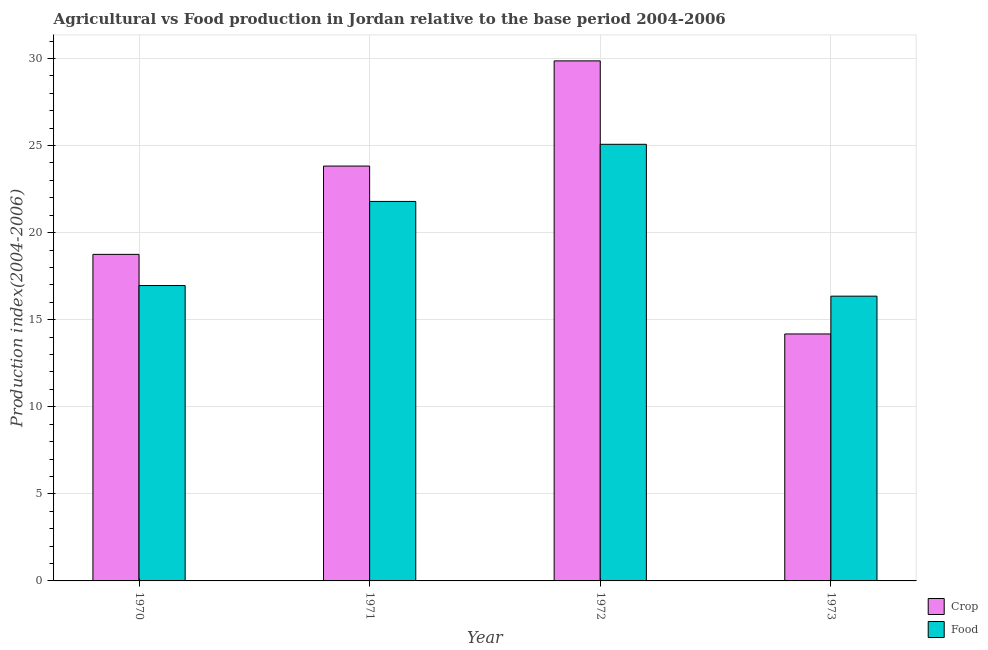How many groups of bars are there?
Keep it short and to the point. 4. Are the number of bars per tick equal to the number of legend labels?
Keep it short and to the point. Yes. Are the number of bars on each tick of the X-axis equal?
Give a very brief answer. Yes. In how many cases, is the number of bars for a given year not equal to the number of legend labels?
Offer a terse response. 0. What is the crop production index in 1972?
Provide a succinct answer. 29.86. Across all years, what is the maximum crop production index?
Offer a very short reply. 29.86. Across all years, what is the minimum crop production index?
Your answer should be compact. 14.18. In which year was the food production index maximum?
Keep it short and to the point. 1972. In which year was the food production index minimum?
Offer a very short reply. 1973. What is the total crop production index in the graph?
Give a very brief answer. 86.61. What is the difference between the crop production index in 1970 and that in 1973?
Keep it short and to the point. 4.57. What is the difference between the crop production index in 1971 and the food production index in 1970?
Your response must be concise. 5.07. What is the average food production index per year?
Make the answer very short. 20.04. What is the ratio of the food production index in 1970 to that in 1972?
Give a very brief answer. 0.68. Is the food production index in 1970 less than that in 1972?
Provide a short and direct response. Yes. What is the difference between the highest and the second highest food production index?
Make the answer very short. 3.28. What is the difference between the highest and the lowest food production index?
Keep it short and to the point. 8.72. Is the sum of the crop production index in 1972 and 1973 greater than the maximum food production index across all years?
Give a very brief answer. Yes. What does the 1st bar from the left in 1973 represents?
Give a very brief answer. Crop. What does the 1st bar from the right in 1973 represents?
Your answer should be compact. Food. What is the difference between two consecutive major ticks on the Y-axis?
Give a very brief answer. 5. Are the values on the major ticks of Y-axis written in scientific E-notation?
Offer a very short reply. No. Does the graph contain grids?
Your answer should be very brief. Yes. How many legend labels are there?
Give a very brief answer. 2. What is the title of the graph?
Your answer should be very brief. Agricultural vs Food production in Jordan relative to the base period 2004-2006. Does "Exports" appear as one of the legend labels in the graph?
Provide a succinct answer. No. What is the label or title of the Y-axis?
Your answer should be very brief. Production index(2004-2006). What is the Production index(2004-2006) in Crop in 1970?
Make the answer very short. 18.75. What is the Production index(2004-2006) in Food in 1970?
Offer a very short reply. 16.96. What is the Production index(2004-2006) in Crop in 1971?
Provide a succinct answer. 23.82. What is the Production index(2004-2006) of Food in 1971?
Your answer should be compact. 21.79. What is the Production index(2004-2006) in Crop in 1972?
Keep it short and to the point. 29.86. What is the Production index(2004-2006) of Food in 1972?
Offer a very short reply. 25.07. What is the Production index(2004-2006) in Crop in 1973?
Provide a succinct answer. 14.18. What is the Production index(2004-2006) in Food in 1973?
Your answer should be compact. 16.35. Across all years, what is the maximum Production index(2004-2006) in Crop?
Your answer should be very brief. 29.86. Across all years, what is the maximum Production index(2004-2006) in Food?
Keep it short and to the point. 25.07. Across all years, what is the minimum Production index(2004-2006) of Crop?
Make the answer very short. 14.18. Across all years, what is the minimum Production index(2004-2006) of Food?
Provide a short and direct response. 16.35. What is the total Production index(2004-2006) in Crop in the graph?
Ensure brevity in your answer.  86.61. What is the total Production index(2004-2006) in Food in the graph?
Your answer should be compact. 80.17. What is the difference between the Production index(2004-2006) of Crop in 1970 and that in 1971?
Your answer should be very brief. -5.07. What is the difference between the Production index(2004-2006) in Food in 1970 and that in 1971?
Give a very brief answer. -4.83. What is the difference between the Production index(2004-2006) of Crop in 1970 and that in 1972?
Your answer should be compact. -11.11. What is the difference between the Production index(2004-2006) in Food in 1970 and that in 1972?
Ensure brevity in your answer.  -8.11. What is the difference between the Production index(2004-2006) of Crop in 1970 and that in 1973?
Provide a succinct answer. 4.57. What is the difference between the Production index(2004-2006) of Food in 1970 and that in 1973?
Make the answer very short. 0.61. What is the difference between the Production index(2004-2006) in Crop in 1971 and that in 1972?
Offer a terse response. -6.04. What is the difference between the Production index(2004-2006) of Food in 1971 and that in 1972?
Your response must be concise. -3.28. What is the difference between the Production index(2004-2006) of Crop in 1971 and that in 1973?
Offer a very short reply. 9.64. What is the difference between the Production index(2004-2006) of Food in 1971 and that in 1973?
Keep it short and to the point. 5.44. What is the difference between the Production index(2004-2006) in Crop in 1972 and that in 1973?
Provide a succinct answer. 15.68. What is the difference between the Production index(2004-2006) in Food in 1972 and that in 1973?
Offer a very short reply. 8.72. What is the difference between the Production index(2004-2006) in Crop in 1970 and the Production index(2004-2006) in Food in 1971?
Offer a very short reply. -3.04. What is the difference between the Production index(2004-2006) of Crop in 1970 and the Production index(2004-2006) of Food in 1972?
Provide a succinct answer. -6.32. What is the difference between the Production index(2004-2006) of Crop in 1970 and the Production index(2004-2006) of Food in 1973?
Ensure brevity in your answer.  2.4. What is the difference between the Production index(2004-2006) in Crop in 1971 and the Production index(2004-2006) in Food in 1972?
Your answer should be very brief. -1.25. What is the difference between the Production index(2004-2006) of Crop in 1971 and the Production index(2004-2006) of Food in 1973?
Your answer should be very brief. 7.47. What is the difference between the Production index(2004-2006) in Crop in 1972 and the Production index(2004-2006) in Food in 1973?
Your response must be concise. 13.51. What is the average Production index(2004-2006) of Crop per year?
Provide a short and direct response. 21.65. What is the average Production index(2004-2006) of Food per year?
Offer a terse response. 20.04. In the year 1970, what is the difference between the Production index(2004-2006) of Crop and Production index(2004-2006) of Food?
Your answer should be compact. 1.79. In the year 1971, what is the difference between the Production index(2004-2006) of Crop and Production index(2004-2006) of Food?
Your response must be concise. 2.03. In the year 1972, what is the difference between the Production index(2004-2006) in Crop and Production index(2004-2006) in Food?
Offer a terse response. 4.79. In the year 1973, what is the difference between the Production index(2004-2006) in Crop and Production index(2004-2006) in Food?
Provide a succinct answer. -2.17. What is the ratio of the Production index(2004-2006) of Crop in 1970 to that in 1971?
Your answer should be compact. 0.79. What is the ratio of the Production index(2004-2006) of Food in 1970 to that in 1971?
Keep it short and to the point. 0.78. What is the ratio of the Production index(2004-2006) of Crop in 1970 to that in 1972?
Keep it short and to the point. 0.63. What is the ratio of the Production index(2004-2006) in Food in 1970 to that in 1972?
Keep it short and to the point. 0.68. What is the ratio of the Production index(2004-2006) in Crop in 1970 to that in 1973?
Offer a very short reply. 1.32. What is the ratio of the Production index(2004-2006) of Food in 1970 to that in 1973?
Offer a terse response. 1.04. What is the ratio of the Production index(2004-2006) in Crop in 1971 to that in 1972?
Make the answer very short. 0.8. What is the ratio of the Production index(2004-2006) in Food in 1971 to that in 1972?
Your answer should be very brief. 0.87. What is the ratio of the Production index(2004-2006) of Crop in 1971 to that in 1973?
Provide a short and direct response. 1.68. What is the ratio of the Production index(2004-2006) in Food in 1971 to that in 1973?
Your answer should be very brief. 1.33. What is the ratio of the Production index(2004-2006) of Crop in 1972 to that in 1973?
Your response must be concise. 2.11. What is the ratio of the Production index(2004-2006) of Food in 1972 to that in 1973?
Ensure brevity in your answer.  1.53. What is the difference between the highest and the second highest Production index(2004-2006) in Crop?
Give a very brief answer. 6.04. What is the difference between the highest and the second highest Production index(2004-2006) of Food?
Your answer should be very brief. 3.28. What is the difference between the highest and the lowest Production index(2004-2006) in Crop?
Your answer should be compact. 15.68. What is the difference between the highest and the lowest Production index(2004-2006) in Food?
Provide a succinct answer. 8.72. 